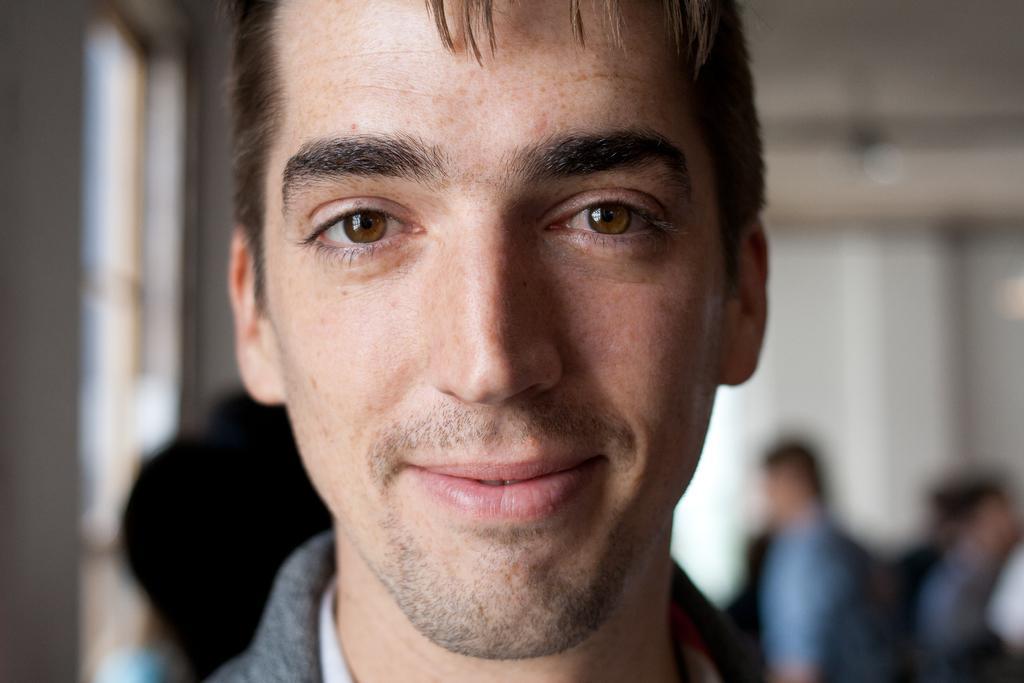Could you give a brief overview of what you see in this image? In the picture we can see a man face with a smile, behind him we can see some people are standing near the wall and beside it we can see a window. 